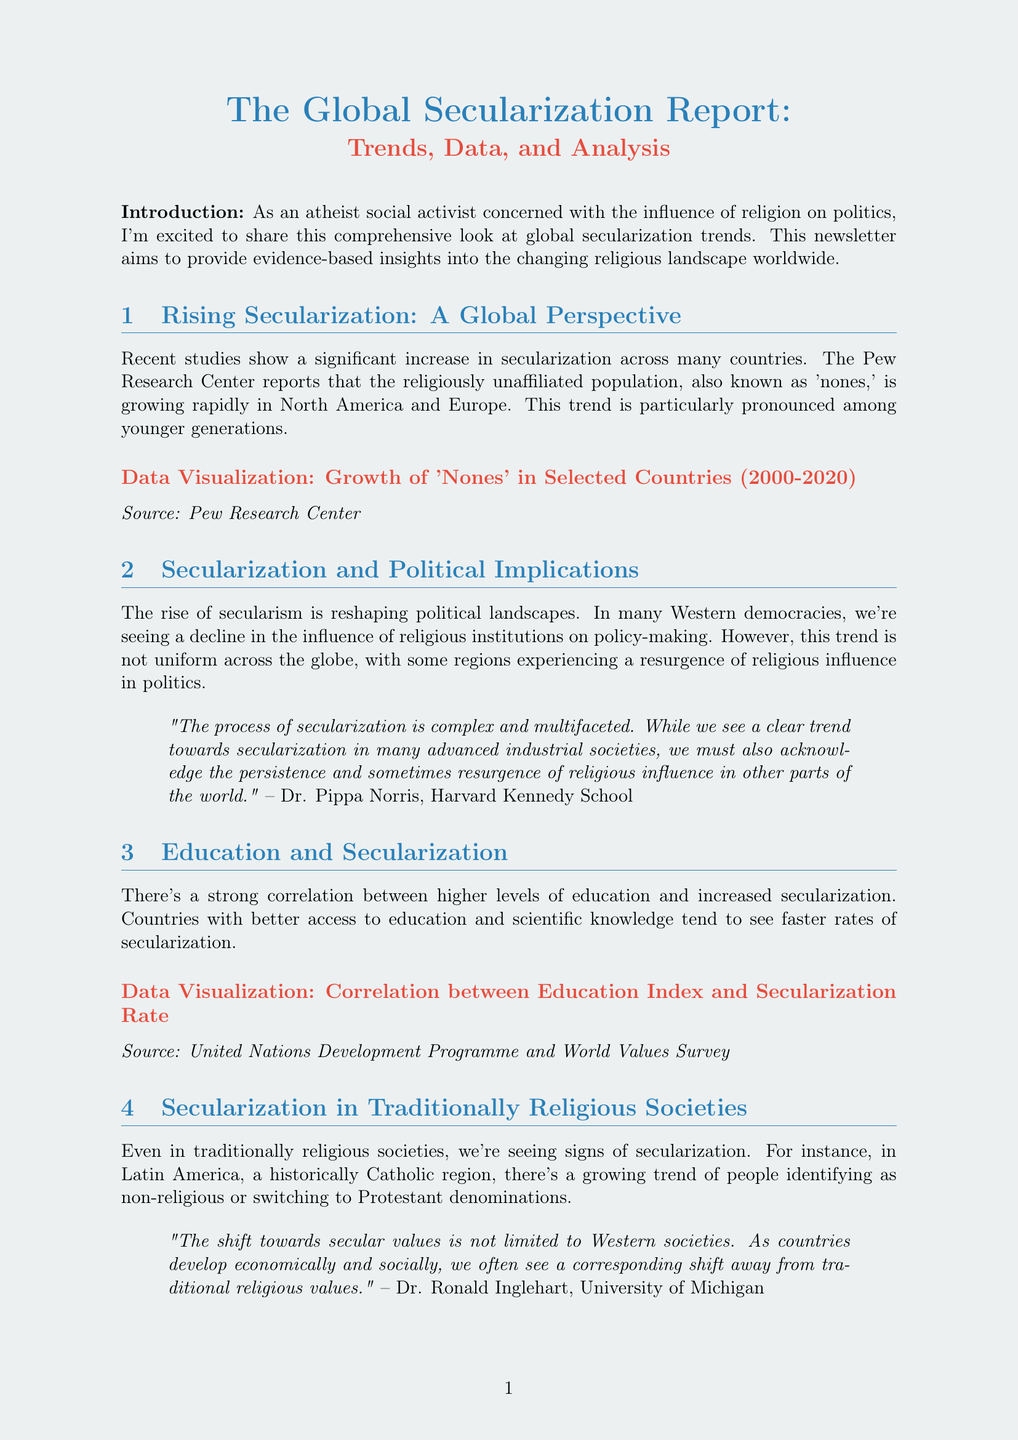What is the title of the newsletter? The title of the newsletter is provided at the beginning, which is the main heading of the document.
Answer: The Global Secularization Report: Trends, Data, and Analysis Who is the author of the expert commentary regarding political implications? The commentary includes the name and affiliation of Dr. Pippa Norris, who is mentioned in the second section.
Answer: Dr. Pippa Norris What trend is noted in North America and Europe? The content discusses a specific increase in a particular demographic group in these regions, particularly among younger generations.
Answer: Growth of 'nones' What is the data visualization type for the growth of 'nones'? The type of visualization used to represent the growth of 'nones' is specified in the corresponding section.
Answer: Line graph What is the correlation between education and secularization? The document states a relationship between two factors in the context of secularization and education.
Answer: Strong correlation Who is the author of the book recommended in the additional resources? The document lists a specific book along with its author as a resource for further reading.
Answer: Charles Taylor What is the main challenge noted in the conclusion regarding secularization? The final section identifies complexities related to a specific issue that requires attention and activism.
Answer: Influence of religion on politics What event is mentioned as a call to action? The document references a specific event that the reader can attend to engage further with the topic.
Answer: Secular Democracy Forum What organization is hosting the upcoming forum? The newsletter specifies the organizing body of a certain event related to secular democracy.
Answer: International Humanist and Ethical Union (IHEU) 